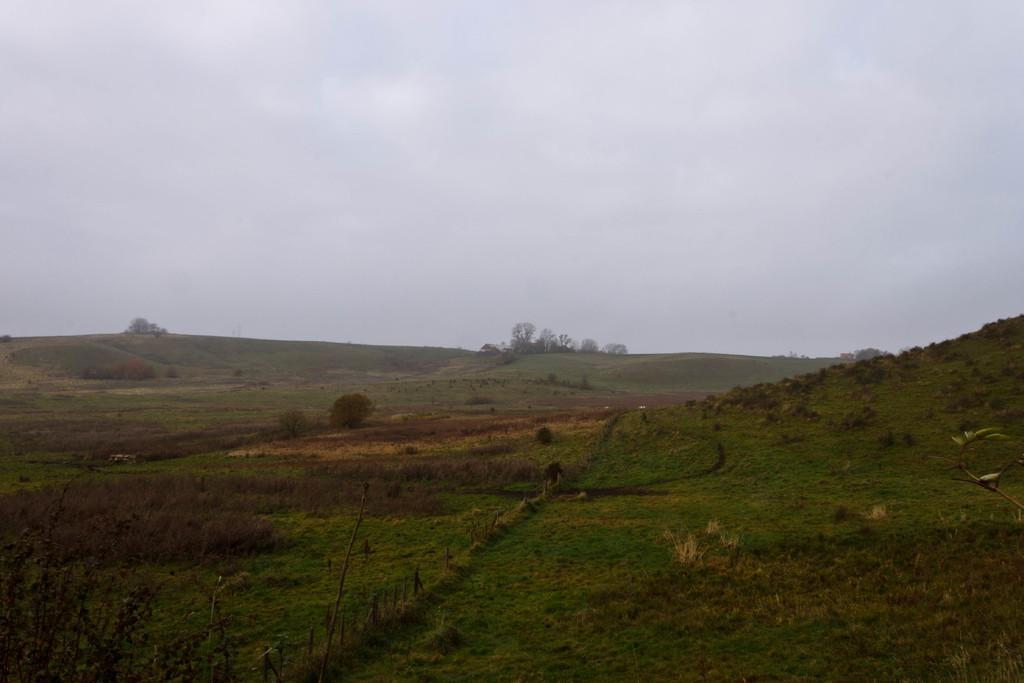What type of vegetation can be seen in the image? There is a group of plants, grass, and trees in the image. What other objects are visible in the image? Wooden poles are visible in the image. What is visible in the background of the image? The sky is visible in the image. What is the condition of the sky in the image? The sky appears to be cloudy in the image. What type of glass objects can be seen in the image? There are no glass objects present in the image. What game is being played in the image? There is no game being played in the image. 